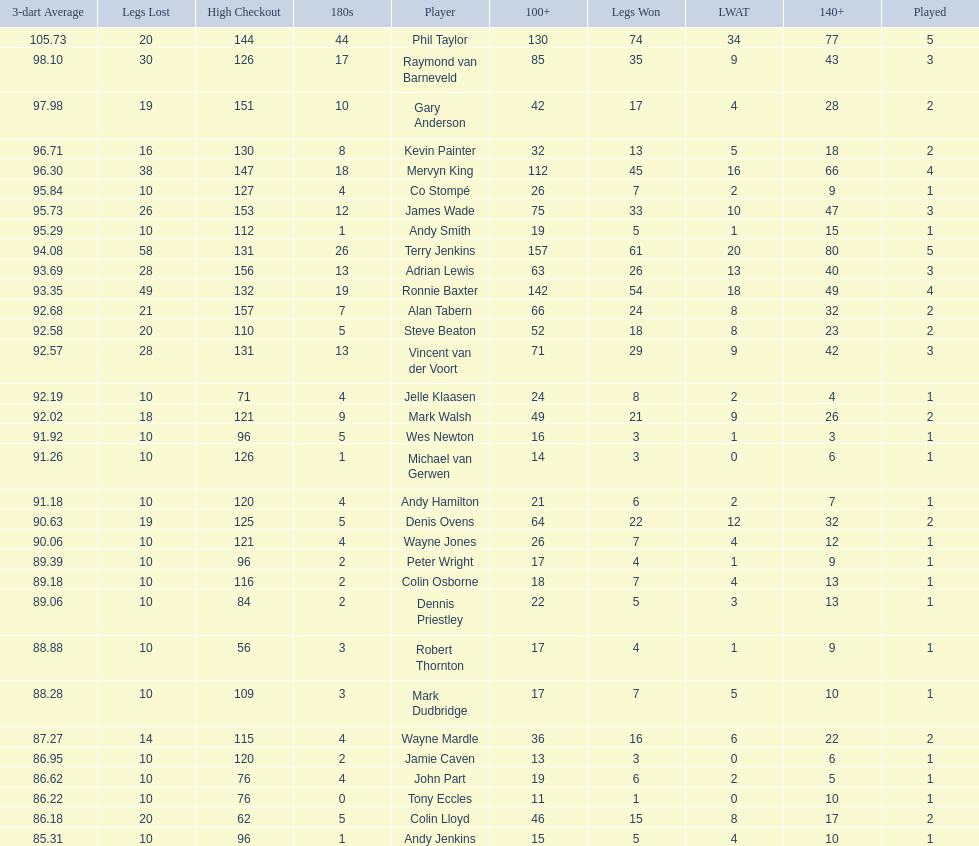How many players in the 2009 world matchplay won at least 30 legs? 6. 